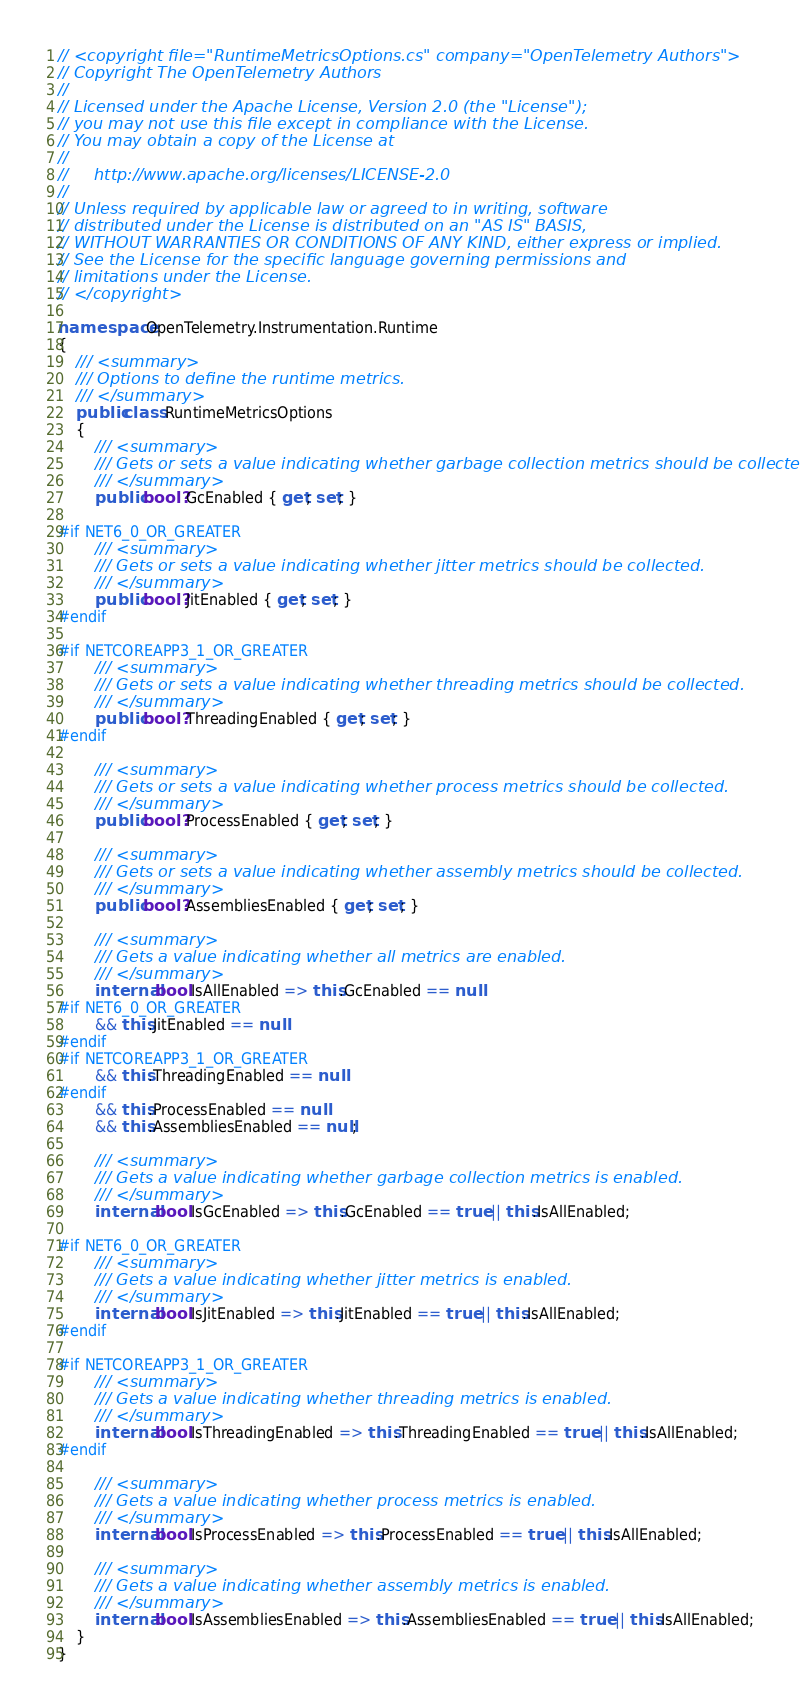Convert code to text. <code><loc_0><loc_0><loc_500><loc_500><_C#_>// <copyright file="RuntimeMetricsOptions.cs" company="OpenTelemetry Authors">
// Copyright The OpenTelemetry Authors
//
// Licensed under the Apache License, Version 2.0 (the "License");
// you may not use this file except in compliance with the License.
// You may obtain a copy of the License at
//
//     http://www.apache.org/licenses/LICENSE-2.0
//
// Unless required by applicable law or agreed to in writing, software
// distributed under the License is distributed on an "AS IS" BASIS,
// WITHOUT WARRANTIES OR CONDITIONS OF ANY KIND, either express or implied.
// See the License for the specific language governing permissions and
// limitations under the License.
// </copyright>

namespace OpenTelemetry.Instrumentation.Runtime
{
    /// <summary>
    /// Options to define the runtime metrics.
    /// </summary>
    public class RuntimeMetricsOptions
    {
        /// <summary>
        /// Gets or sets a value indicating whether garbage collection metrics should be collected.
        /// </summary>
        public bool? GcEnabled { get; set; }

#if NET6_0_OR_GREATER
        /// <summary>
        /// Gets or sets a value indicating whether jitter metrics should be collected.
        /// </summary>
        public bool? JitEnabled { get; set; }
#endif

#if NETCOREAPP3_1_OR_GREATER
        /// <summary>
        /// Gets or sets a value indicating whether threading metrics should be collected.
        /// </summary>
        public bool? ThreadingEnabled { get; set; }
#endif

        /// <summary>
        /// Gets or sets a value indicating whether process metrics should be collected.
        /// </summary>
        public bool? ProcessEnabled { get; set; }

        /// <summary>
        /// Gets or sets a value indicating whether assembly metrics should be collected.
        /// </summary>
        public bool? AssembliesEnabled { get; set; }

        /// <summary>
        /// Gets a value indicating whether all metrics are enabled.
        /// </summary>
        internal bool IsAllEnabled => this.GcEnabled == null
#if NET6_0_OR_GREATER
        && this.JitEnabled == null
#endif
#if NETCOREAPP3_1_OR_GREATER
        && this.ThreadingEnabled == null
#endif
        && this.ProcessEnabled == null
        && this.AssembliesEnabled == null;

        /// <summary>
        /// Gets a value indicating whether garbage collection metrics is enabled.
        /// </summary>
        internal bool IsGcEnabled => this.GcEnabled == true || this.IsAllEnabled;

#if NET6_0_OR_GREATER
        /// <summary>
        /// Gets a value indicating whether jitter metrics is enabled.
        /// </summary>
        internal bool IsJitEnabled => this.JitEnabled == true || this.IsAllEnabled;
#endif

#if NETCOREAPP3_1_OR_GREATER
        /// <summary>
        /// Gets a value indicating whether threading metrics is enabled.
        /// </summary>
        internal bool IsThreadingEnabled => this.ThreadingEnabled == true || this.IsAllEnabled;
#endif

        /// <summary>
        /// Gets a value indicating whether process metrics is enabled.
        /// </summary>
        internal bool IsProcessEnabled => this.ProcessEnabled == true || this.IsAllEnabled;

        /// <summary>
        /// Gets a value indicating whether assembly metrics is enabled.
        /// </summary>
        internal bool IsAssembliesEnabled => this.AssembliesEnabled == true || this.IsAllEnabled;
    }
}
</code> 